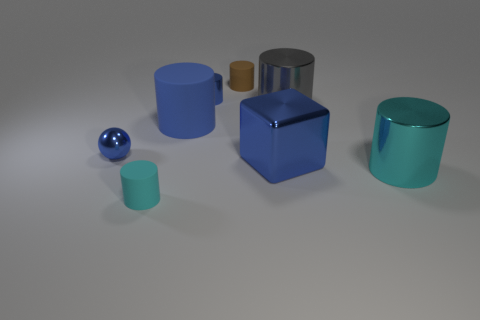Subtract 3 cylinders. How many cylinders are left? 3 Subtract all brown matte cylinders. How many cylinders are left? 5 Subtract all gray cylinders. How many cylinders are left? 5 Subtract all purple cylinders. Subtract all red spheres. How many cylinders are left? 6 Add 1 tiny red cylinders. How many objects exist? 9 Subtract all spheres. How many objects are left? 7 Subtract all cyan metal things. Subtract all small purple rubber cylinders. How many objects are left? 7 Add 8 large metallic cylinders. How many large metallic cylinders are left? 10 Add 6 yellow cubes. How many yellow cubes exist? 6 Subtract 0 purple spheres. How many objects are left? 8 